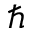<formula> <loc_0><loc_0><loc_500><loc_500>\hbar</formula> 